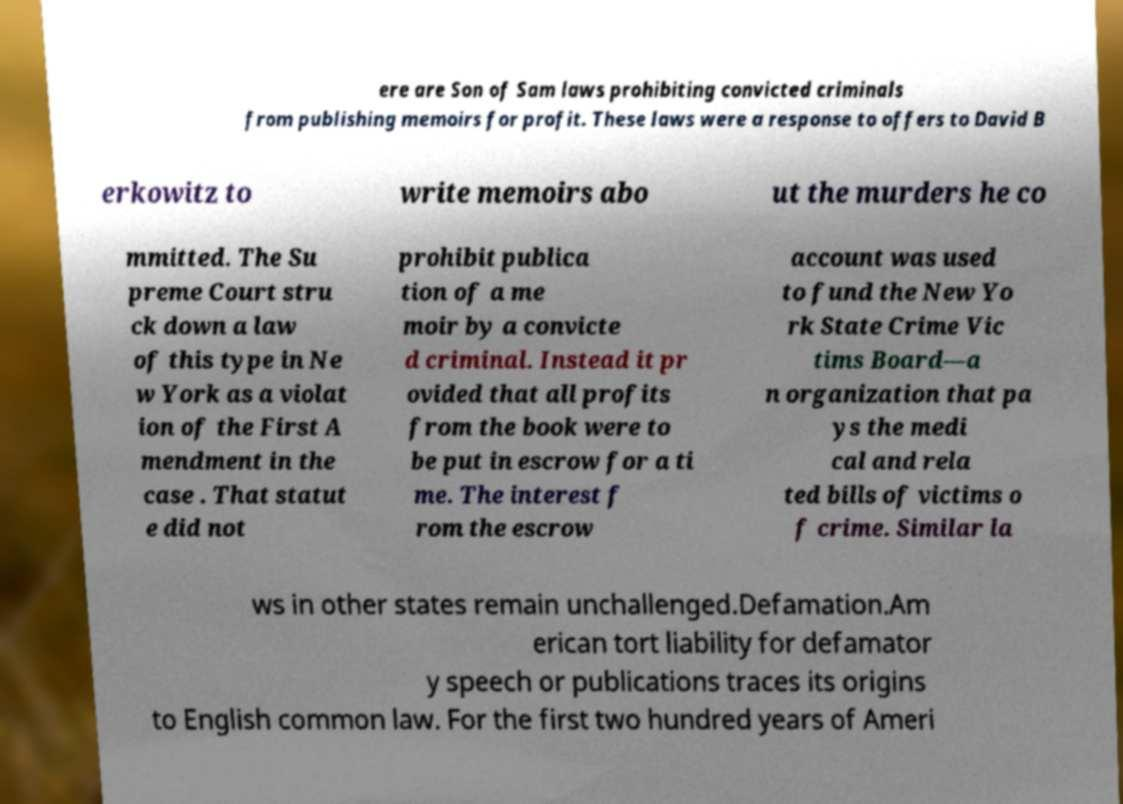There's text embedded in this image that I need extracted. Can you transcribe it verbatim? ere are Son of Sam laws prohibiting convicted criminals from publishing memoirs for profit. These laws were a response to offers to David B erkowitz to write memoirs abo ut the murders he co mmitted. The Su preme Court stru ck down a law of this type in Ne w York as a violat ion of the First A mendment in the case . That statut e did not prohibit publica tion of a me moir by a convicte d criminal. Instead it pr ovided that all profits from the book were to be put in escrow for a ti me. The interest f rom the escrow account was used to fund the New Yo rk State Crime Vic tims Board—a n organization that pa ys the medi cal and rela ted bills of victims o f crime. Similar la ws in other states remain unchallenged.Defamation.Am erican tort liability for defamator y speech or publications traces its origins to English common law. For the first two hundred years of Ameri 